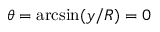<formula> <loc_0><loc_0><loc_500><loc_500>\theta = \arcsin ( y / R ) = 0</formula> 